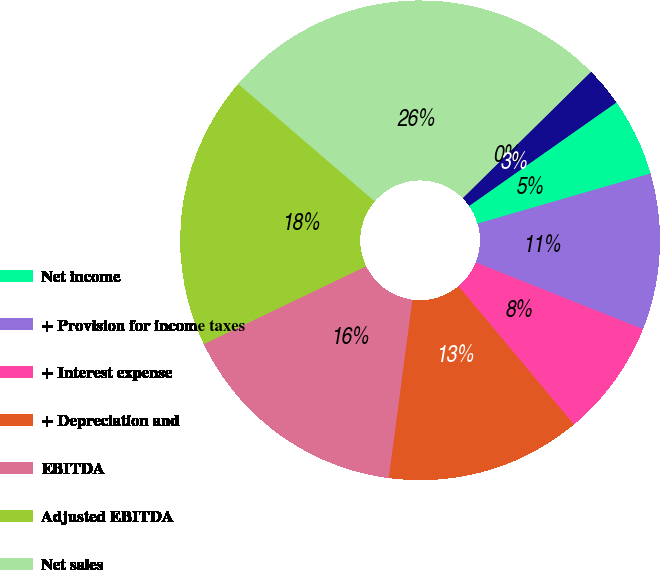Convert chart. <chart><loc_0><loc_0><loc_500><loc_500><pie_chart><fcel>Net income<fcel>+ Provision for income taxes<fcel>+ Interest expense<fcel>+ Depreciation and<fcel>EBITDA<fcel>Adjusted EBITDA<fcel>Net sales<fcel>EBITDA margin<fcel>Adjusted EBITDA margin<nl><fcel>5.26%<fcel>10.53%<fcel>7.89%<fcel>13.16%<fcel>15.79%<fcel>18.42%<fcel>26.32%<fcel>0.0%<fcel>2.63%<nl></chart> 